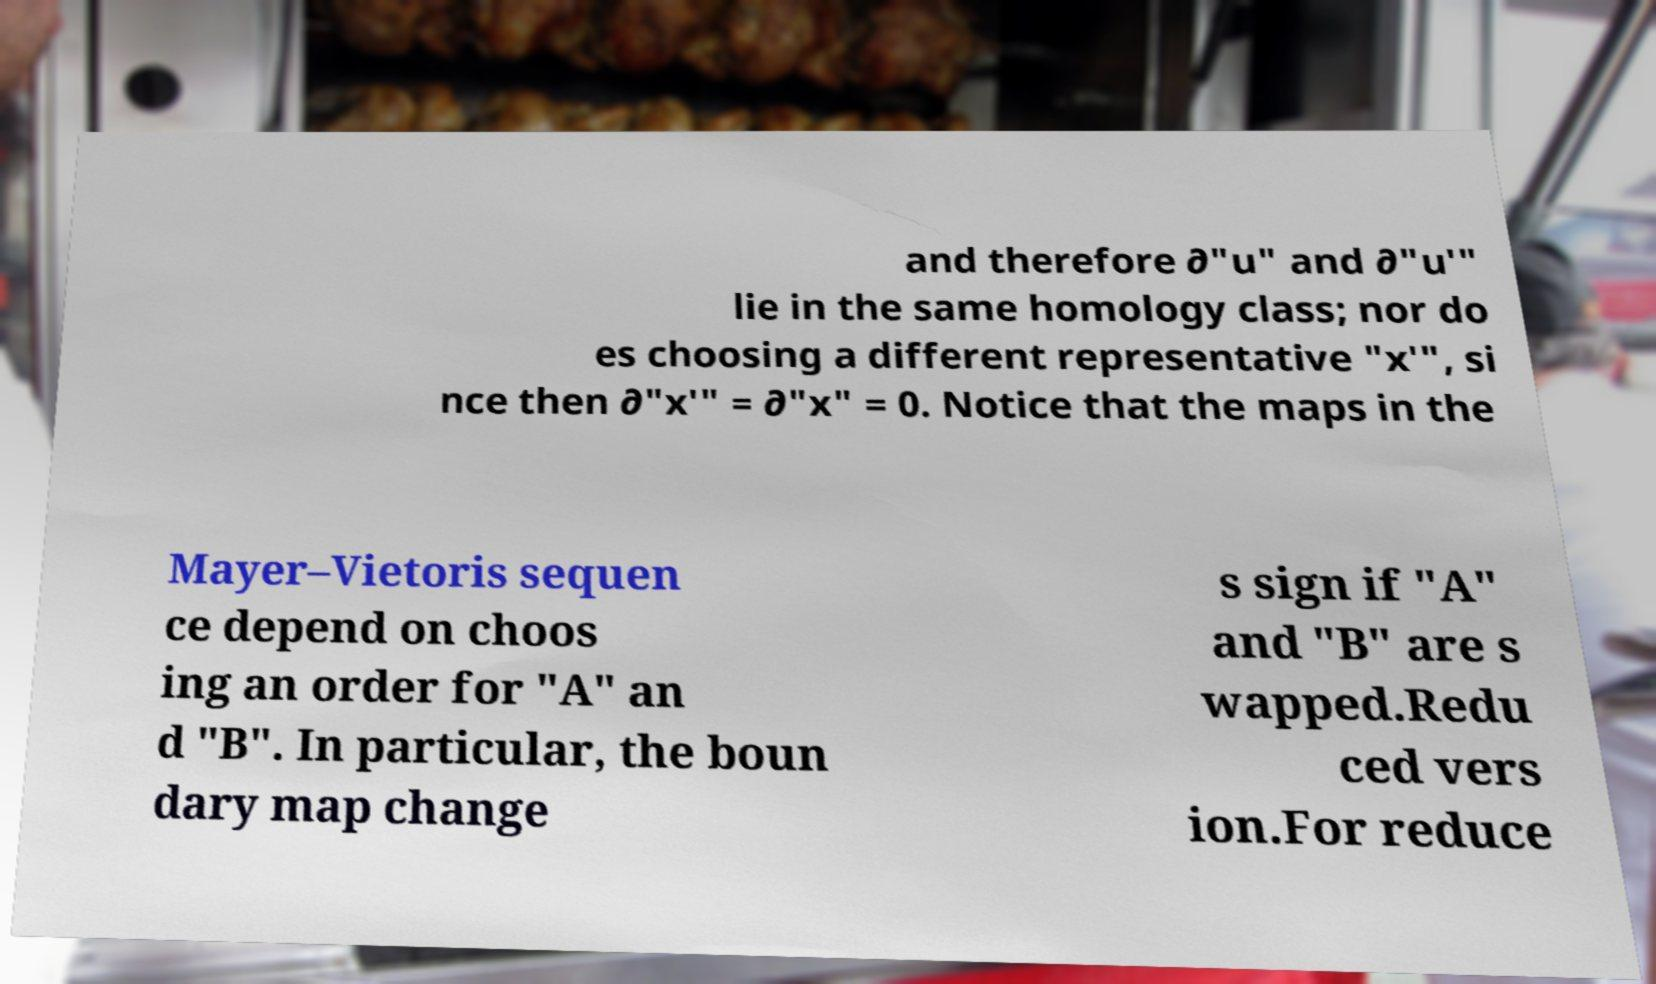Can you read and provide the text displayed in the image?This photo seems to have some interesting text. Can you extract and type it out for me? and therefore ∂"u" and ∂"u′" lie in the same homology class; nor do es choosing a different representative "x′", si nce then ∂"x′" = ∂"x" = 0. Notice that the maps in the Mayer–Vietoris sequen ce depend on choos ing an order for "A" an d "B". In particular, the boun dary map change s sign if "A" and "B" are s wapped.Redu ced vers ion.For reduce 